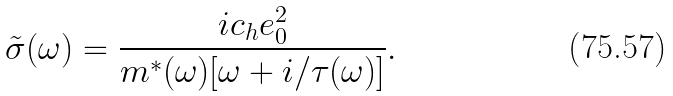<formula> <loc_0><loc_0><loc_500><loc_500>\tilde { \sigma } ( \omega ) = \frac { i c _ { h } e _ { 0 } ^ { 2 } } { m ^ { * } ( \omega ) [ \omega + i / \tau ( \omega ) ] } .</formula> 